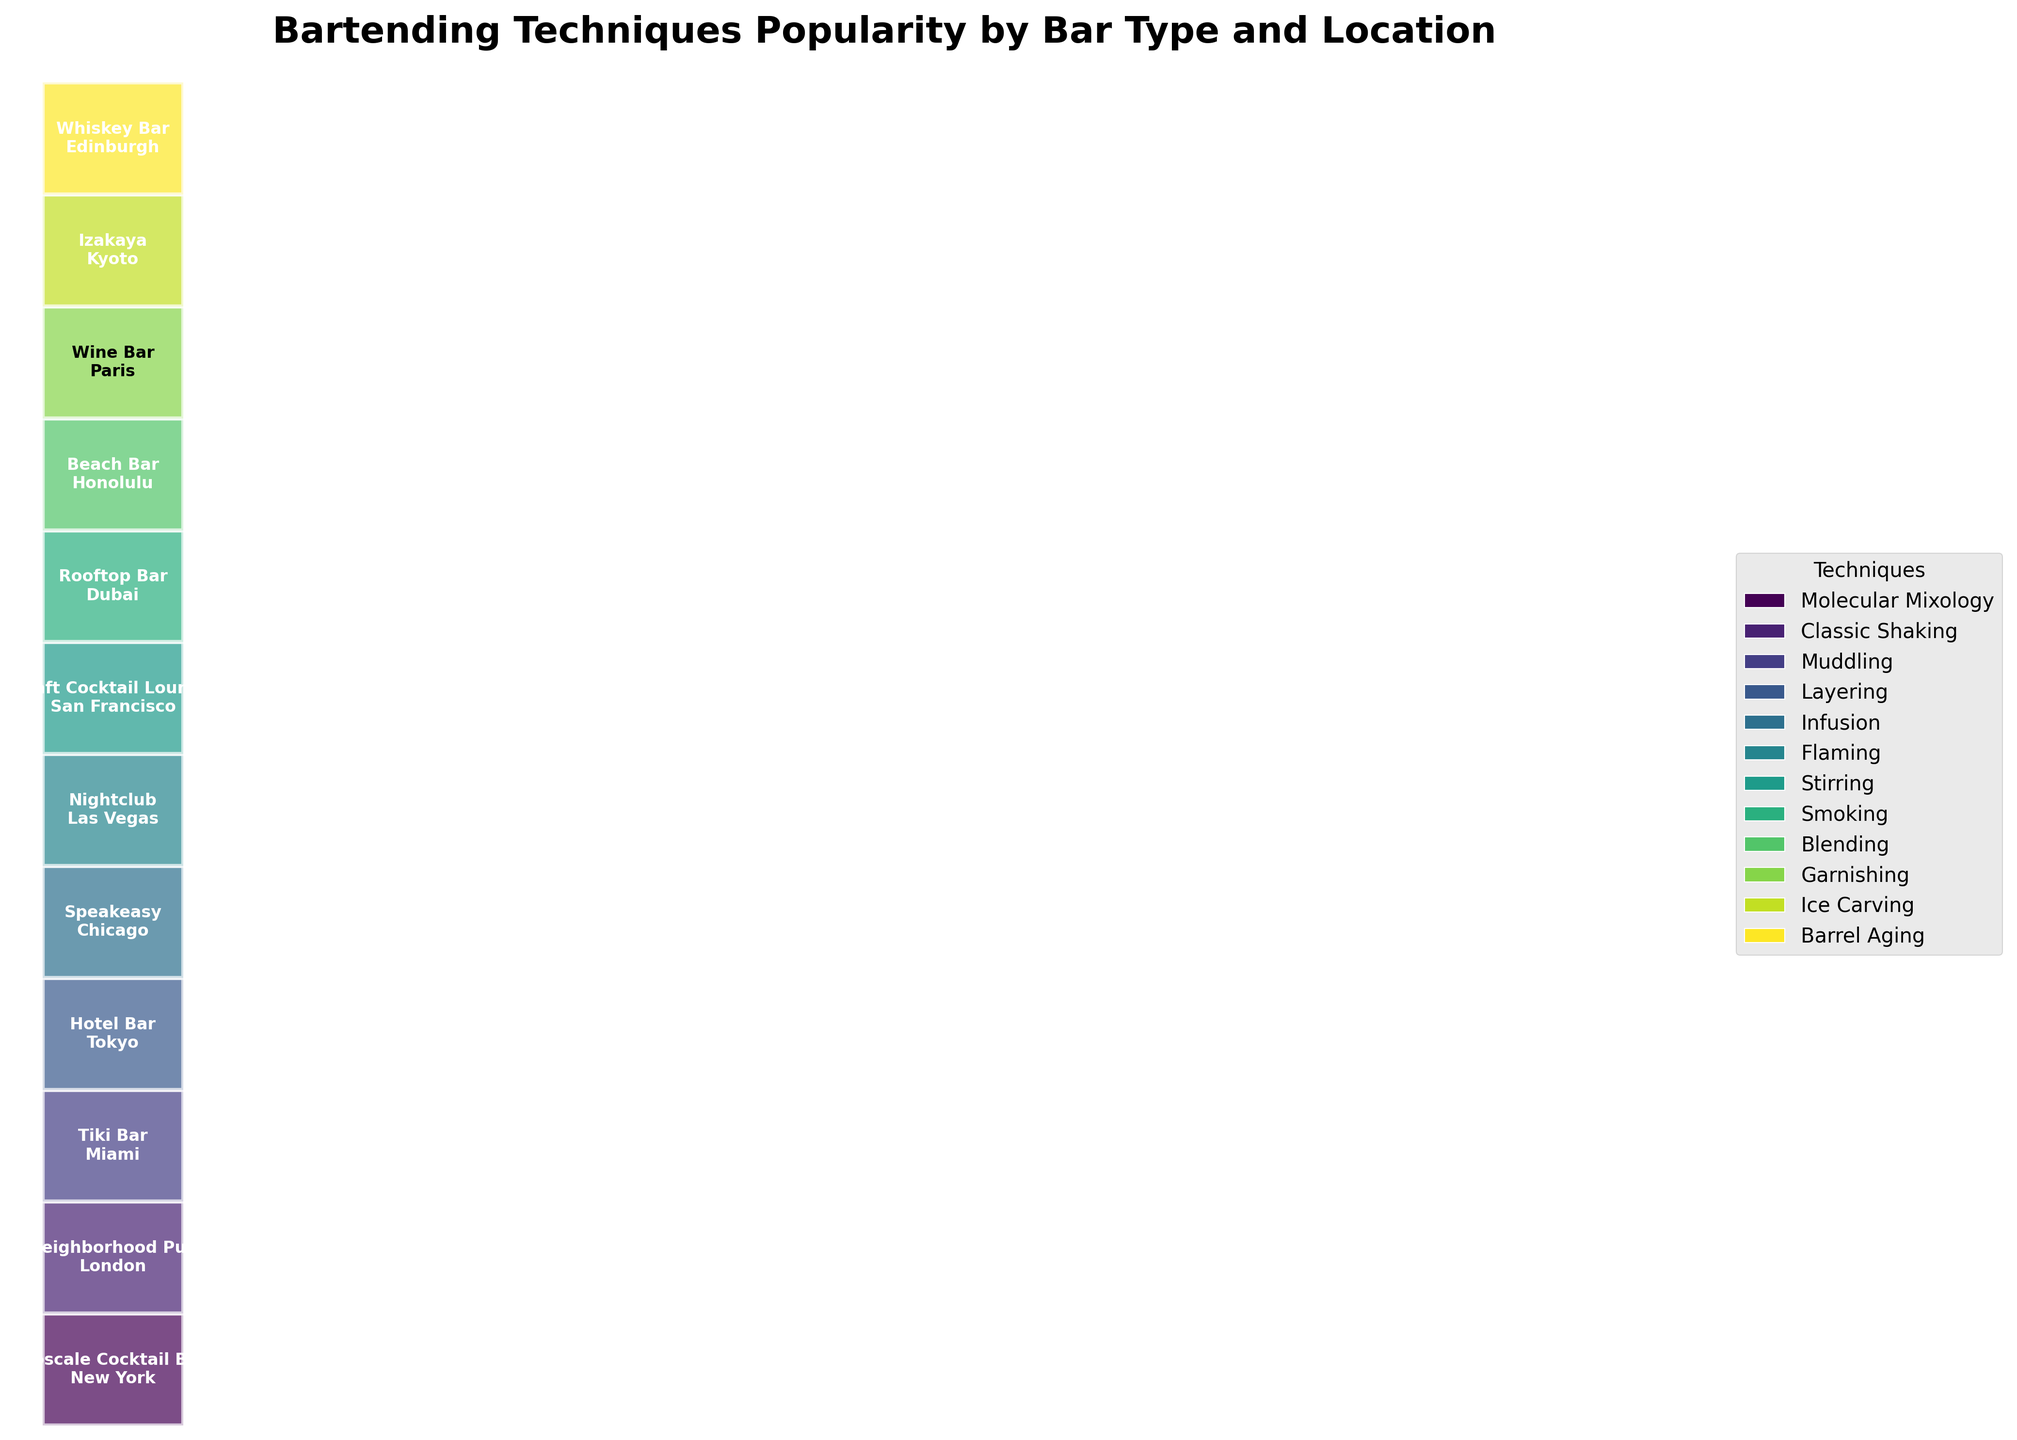What is the title of the figure? The title is usually located at the top of the figure. In this case, by looking at the plot, we can see the title clearly.
Answer: Bartending Techniques Popularity by Bar Type and Location How many different bartending techniques are shown in the figure? The figure has a legend with colored rectangles, each representing a different bartending technique. Count the number of unique colors to determine the number of different techniques.
Answer: 12 Which bartending technique has the highest popularity in New York? Review the rectangles that list "New York" within them and identify the technique associated with the "High" popularity level.
Answer: Molecular Mixology How does the popularity of 'Smoking' in Dubai compare to 'Flaming' in Las Vegas? Locate the rectangles for 'Smoking' in Dubai and 'Flaming' in Las Vegas and compare their listed popularity.
Answer: Both have medium popularity Which bar type in Tokyo uses 'Layering' and what’s its popularity? Find the rectangle that lists "Tokyo" and "Layering". Identify the bar type and popularity stated inside.
Answer: Hotel Bar, Medium In which location is 'Classic Shaking' popular and how popular is it? Locate the rectangle that lists "Classic Shaking" and identify the corresponding location. Then, read the popularity level mentioned.
Answer: London, Medium Are there more bar types with 'High' popularity or 'Medium' popularity techniques? Count the rectangles labeled with 'High' and those labeled 'Medium' in the figure. Compare the totals.
Answer: High Which location is associated with 'Blending' and what’s the popularity level? Locate the rectangle that lists "Blending" and identify the corresponding location and its popularity.
Answer: Honolulu, High How many bar types are presented in the figure? The bar types are listed in the rectangles. Count the number of unique bar types to get the total count.
Answer: 12 Is there any bartending technique with 'Low' popularity, and if yes, which one? Look for any rectangle labeled with 'Low' popularity and identify the corresponding bartending technique.
Answer: Garnishing 